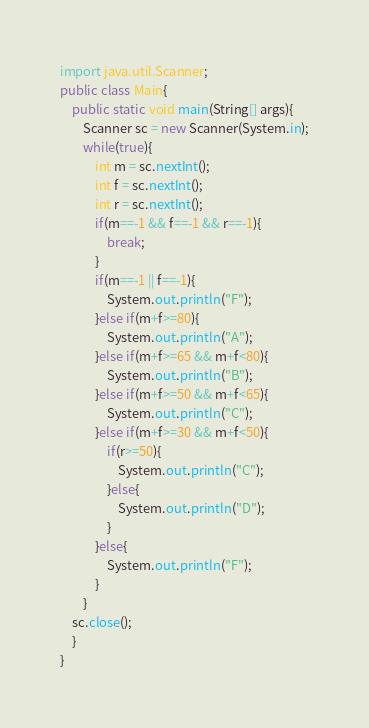Convert code to text. <code><loc_0><loc_0><loc_500><loc_500><_Java_>import java.util.Scanner;
public class Main{
    public static void main(String[] args){
        Scanner sc = new Scanner(System.in);
        while(true){
            int m = sc.nextInt();
            int f = sc.nextInt();
            int r = sc.nextInt();
            if(m==-1 && f==-1 && r==-1){
                break;
            }
            if(m==-1 || f==-1){
                System.out.println("F");
            }else if(m+f>=80){
                System.out.println("A");
            }else if(m+f>=65 && m+f<80){
                System.out.println("B");
            }else if(m+f>=50 && m+f<65){
                System.out.println("C");
            }else if(m+f>=30 && m+f<50){
                if(r>=50){
                    System.out.println("C");
                }else{
                    System.out.println("D");
                }
            }else{
                System.out.println("F");
            }
        }    
    sc.close();
    }
}
</code> 